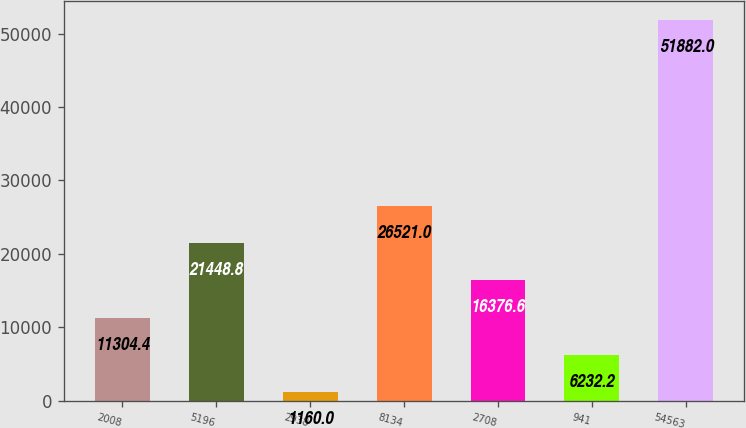<chart> <loc_0><loc_0><loc_500><loc_500><bar_chart><fcel>2008<fcel>5196<fcel>2938<fcel>8134<fcel>2708<fcel>941<fcel>54563<nl><fcel>11304.4<fcel>21448.8<fcel>1160<fcel>26521<fcel>16376.6<fcel>6232.2<fcel>51882<nl></chart> 